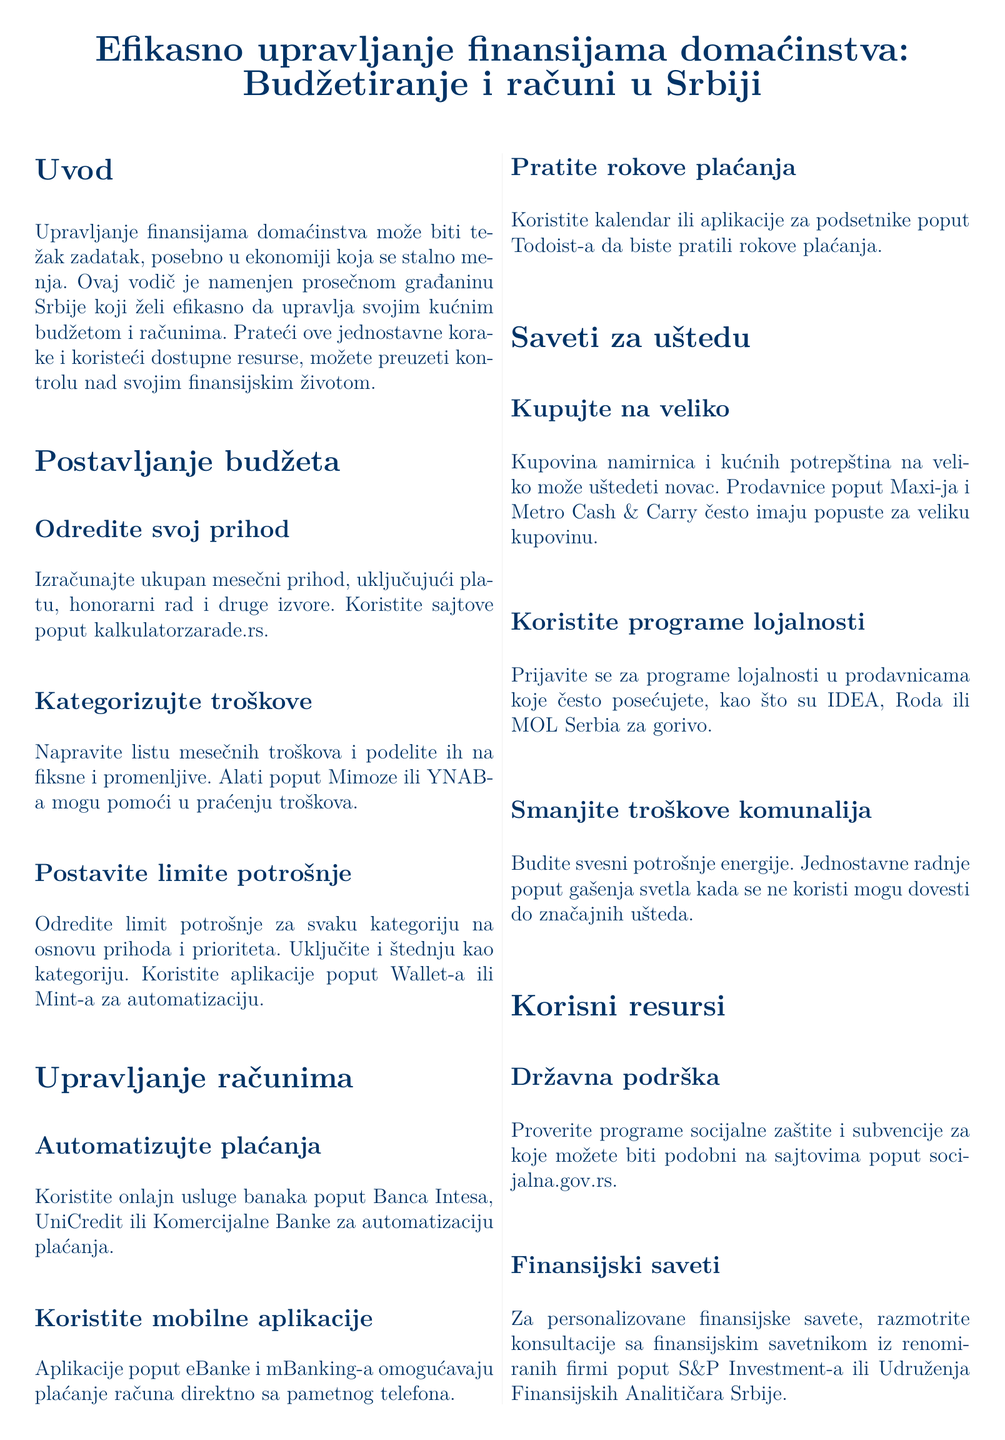Koji alati pomažu u praćenju troškova? U odeljku "Kategorizujte troškove", navedeni su alati kao što su Mimoza i YNAB za praćenje troškova.
Answer: Mimoza, YNAB Kako mogu automatizovati plaćanje računa? U odeljku "Automatizujte plaćanja" se preporučuje korišćenje onlajn usluga banaka kao što su Banca Intesa, UniCredit ili Komercijalna Banka.
Answer: Banca Intesa, UniCredit, Komercijalna Banka Koje su preporuke za smanjenje troškova komunalija? U odeljku "Smanjite troškove komunalija", savetuju se jednostavne radnje poput gašenja svetla kada se ne koristi.
Answer: Gašenje svetla Koje aplikacije se preporučuju za praćenje rokova plaćanja? U odeljku "Pratite rokove plaćanja", spominje se korišćenje aplikacija kao što su Todoist-a.
Answer: Todoist Kako se savetuje štednja prilikom kupovine? U odeljku "Kupujte na veliko", preporučuje se kupovina namirnica i kućnih potrepština na veliko.
Answer: Kupovina na veliko 